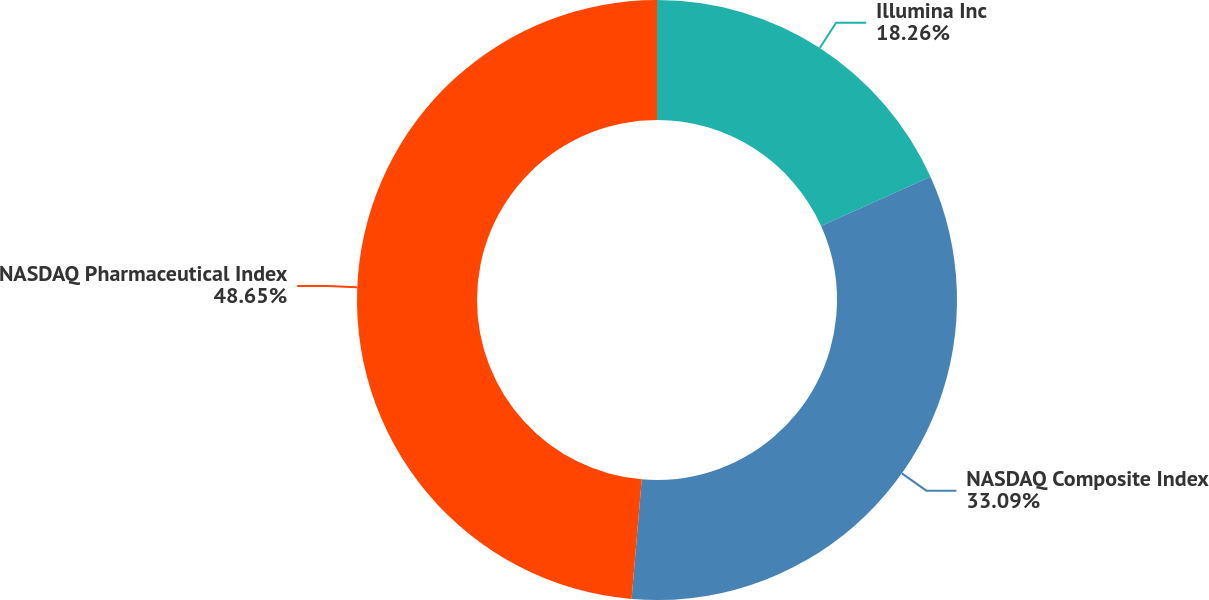Convert chart to OTSL. <chart><loc_0><loc_0><loc_500><loc_500><pie_chart><fcel>Illumina Inc<fcel>NASDAQ Composite Index<fcel>NASDAQ Pharmaceutical Index<nl><fcel>18.26%<fcel>33.09%<fcel>48.65%<nl></chart> 